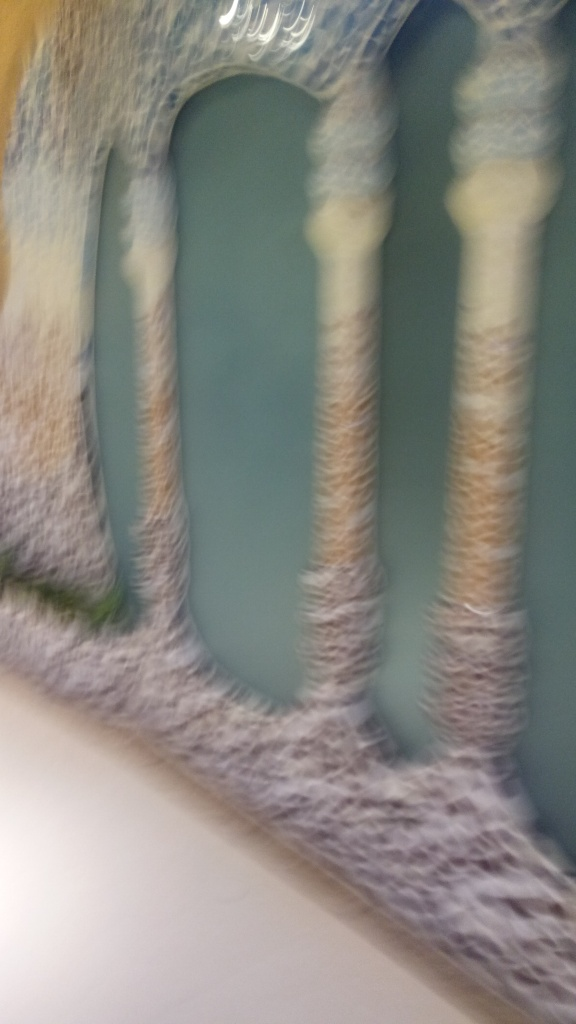What emotions or artistic expressions might this blur convey intentionally? If the blur is intentional, it might convey a sense of motion, haste, or a dream-like, ethereal quality. Artistically, it can be used to emphasize emotions of confusion, the passage of time, or to focus the viewer's attention on the feeling of a scene rather than the details. It might also evoke mystery or the impression of memory, where clarity is not as important as the overall sensation. 